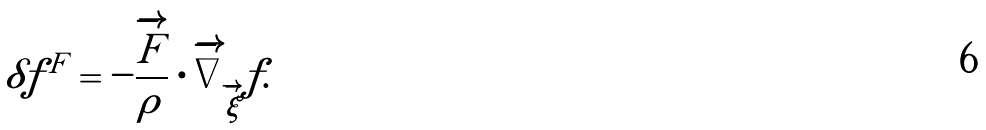<formula> <loc_0><loc_0><loc_500><loc_500>\delta f ^ { F } = - \frac { \overrightarrow { F } } { \rho } \cdot \overrightarrow { \nabla } _ { \overrightarrow { \xi } } f .</formula> 